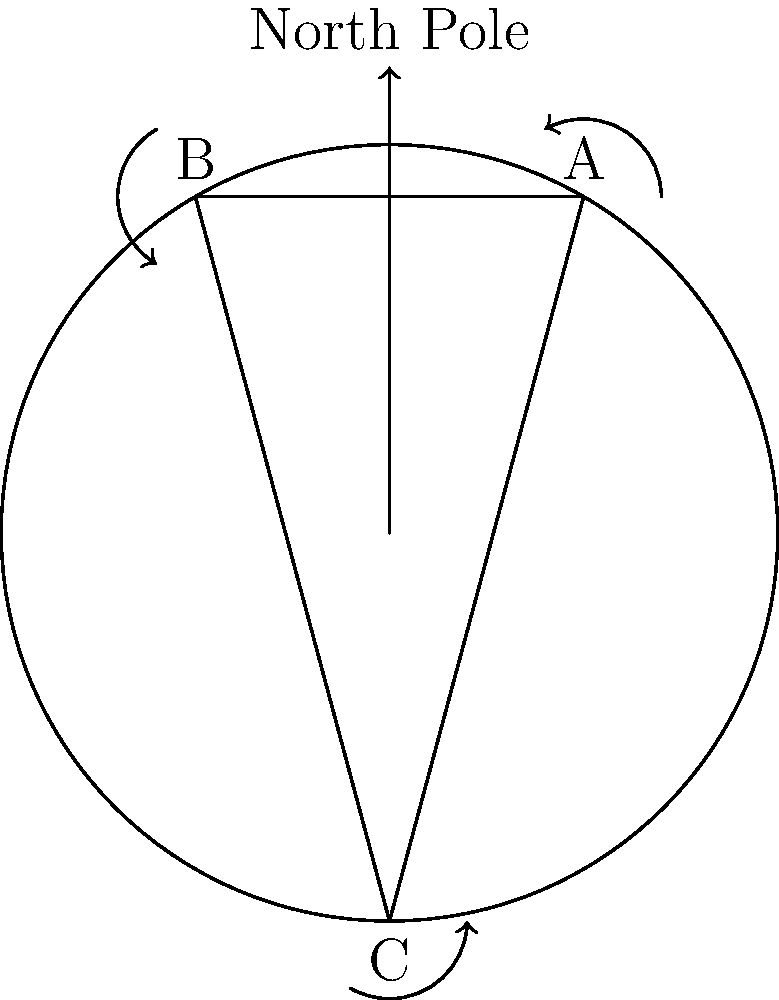In your artistic challenge to illustrate parallel transport on a curved surface, you decide to use a spherical canvas. If you start with a vector at point A and parallel transport it along the path A → B → C → A, what will be the angular difference between the initial and final orientations of the vector? To understand this problem, let's break it down step-by-step:

1) Parallel transport on a curved surface means moving a vector along a path while keeping it as parallel as possible to its previous position.

2) On a flat surface, parallel transport would result in no change in the vector's orientation. However, on a curved surface like a sphere, the curvature causes the vector to rotate.

3) The amount of rotation depends on the area enclosed by the path and the curvature of the surface.

4) For a sphere, the total rotation angle θ is related to the solid angle Ω subtended by the path at the center of the sphere:

   θ = Ω

5) The solid angle of a spherical triangle is given by the spherical excess formula:

   Ω = α + β + γ - π

   where α, β, and γ are the interior angles of the spherical triangle.

6) In this case, we have an equilateral spherical triangle (all sides are great circle arcs of equal length). For such a triangle on a unit sphere, each interior angle is 2π/3.

7) Substituting into the spherical excess formula:

   Ω = 2π/3 + 2π/3 + 2π/3 - π = π

8) Therefore, the total rotation angle θ = π = 180°.

This means that after parallel transport around the closed path, the vector will have rotated by 180° compared to its initial orientation.
Answer: 180° 